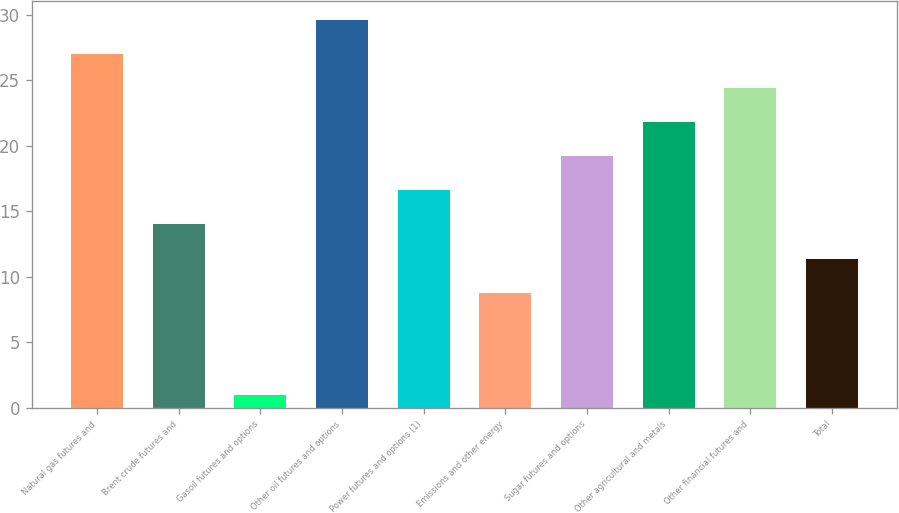<chart> <loc_0><loc_0><loc_500><loc_500><bar_chart><fcel>Natural gas futures and<fcel>Brent crude futures and<fcel>Gasoil futures and options<fcel>Other oil futures and options<fcel>Power futures and options (1)<fcel>Emissions and other energy<fcel>Sugar futures and options<fcel>Other agricultural and metals<fcel>Other financial futures and<fcel>Total<nl><fcel>27<fcel>14<fcel>1<fcel>29.6<fcel>16.6<fcel>8.8<fcel>19.2<fcel>21.8<fcel>24.4<fcel>11.4<nl></chart> 